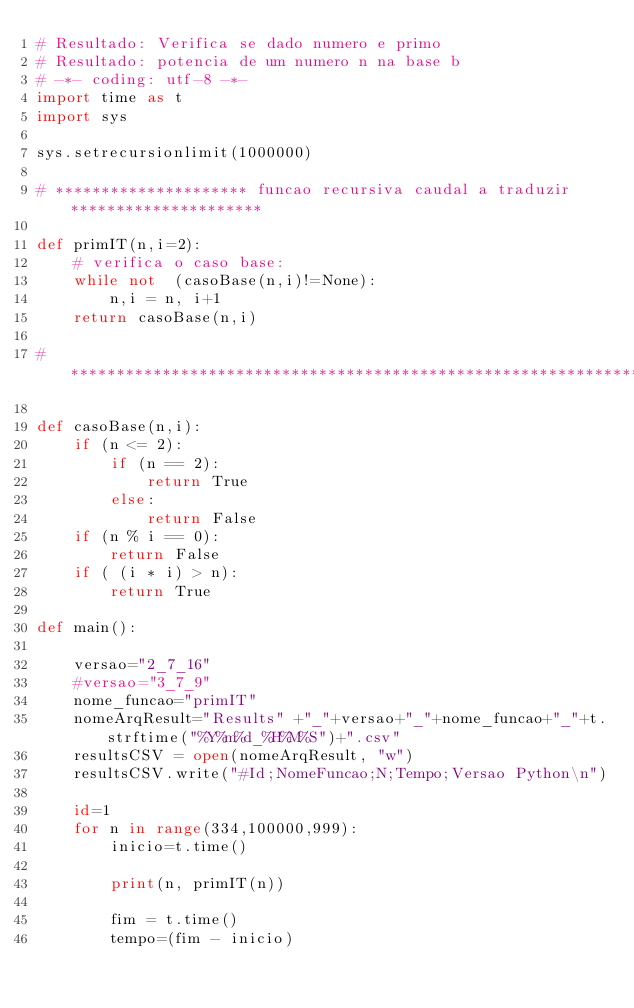<code> <loc_0><loc_0><loc_500><loc_500><_Python_># Resultado: Verifica se dado numero e primo
# Resultado: potencia de um numero n na base b
# -*- coding: utf-8 -*-
import time as t
import sys

sys.setrecursionlimit(1000000)

# ********************* funcao recursiva caudal a traduzir *********************

def primIT(n,i=2):    
    # verifica o caso base:    
    while not  (casoBase(n,i)!=None):
        n,i = n, i+1
    return casoBase(n,i)

# ******************************************************************************

def casoBase(n,i):
    if (n <= 2): 
        if (n == 2):
            return True
        else:
            return False
    if (n % i == 0): 
        return False
    if ( (i * i) > n): 
        return True 

def main():    

    versao="2_7_16"
    #versao="3_7_9"
    nome_funcao="primIT"
    nomeArqResult="Results" +"_"+versao+"_"+nome_funcao+"_"+t.strftime("%Y%m%d_%H%M%S")+".csv"    
    resultsCSV = open(nomeArqResult, "w")
    resultsCSV.write("#Id;NomeFuncao;N;Tempo;Versao Python\n")
    
    id=1    
    for n in range(334,100000,999):
        inicio=t.time()

        print(n, primIT(n))
 
        fim = t.time()
        tempo=(fim - inicio)</code> 